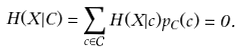<formula> <loc_0><loc_0><loc_500><loc_500>H ( X | C ) = \sum _ { c \in \mathcal { C } } H ( X | c ) p _ { C } ( c ) = 0 .</formula> 